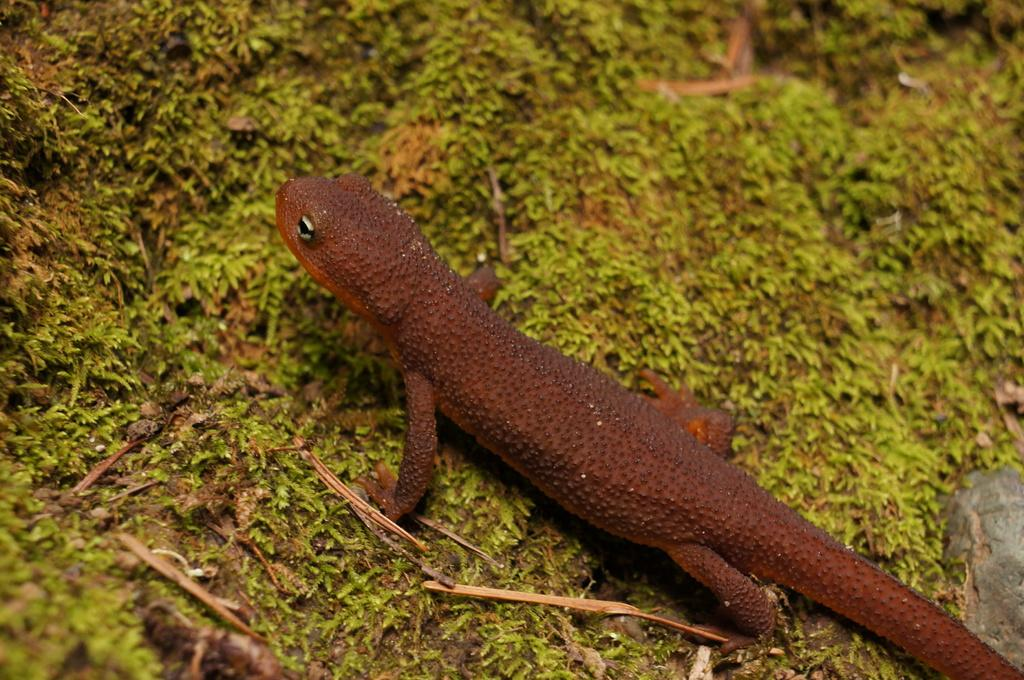What type of animal is in the image? There is a reptile in the image. What other elements can be seen in the image? There are tiny plants in the image. How many kittens are being taught by the reptile in the image? There are no kittens or teaching activity present in the image. What type of vegetable is being grown by the tiny plants in the image? The image does not provide information about the type of vegetable being grown by the tiny plants. 